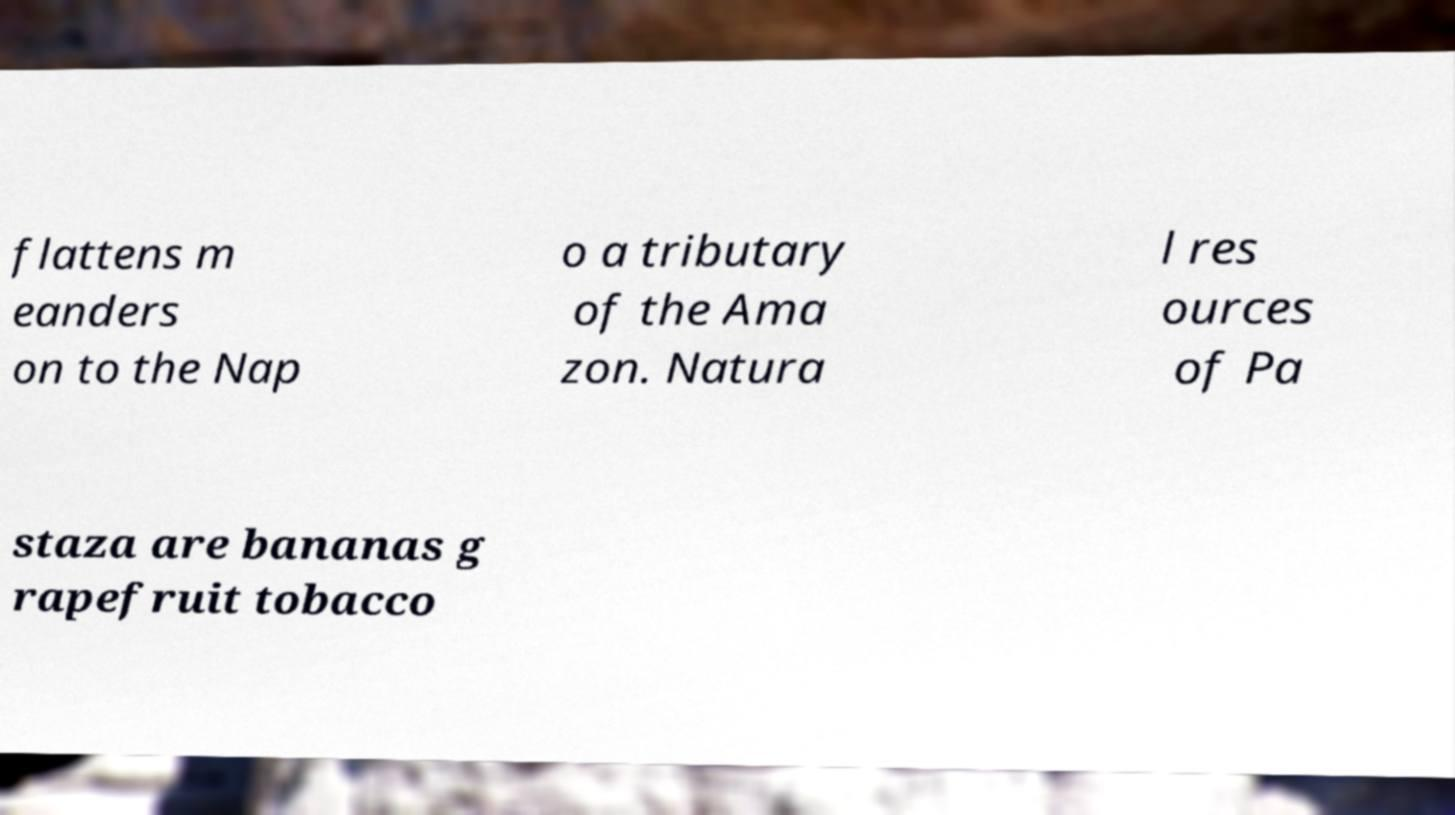Please identify and transcribe the text found in this image. flattens m eanders on to the Nap o a tributary of the Ama zon. Natura l res ources of Pa staza are bananas g rapefruit tobacco 